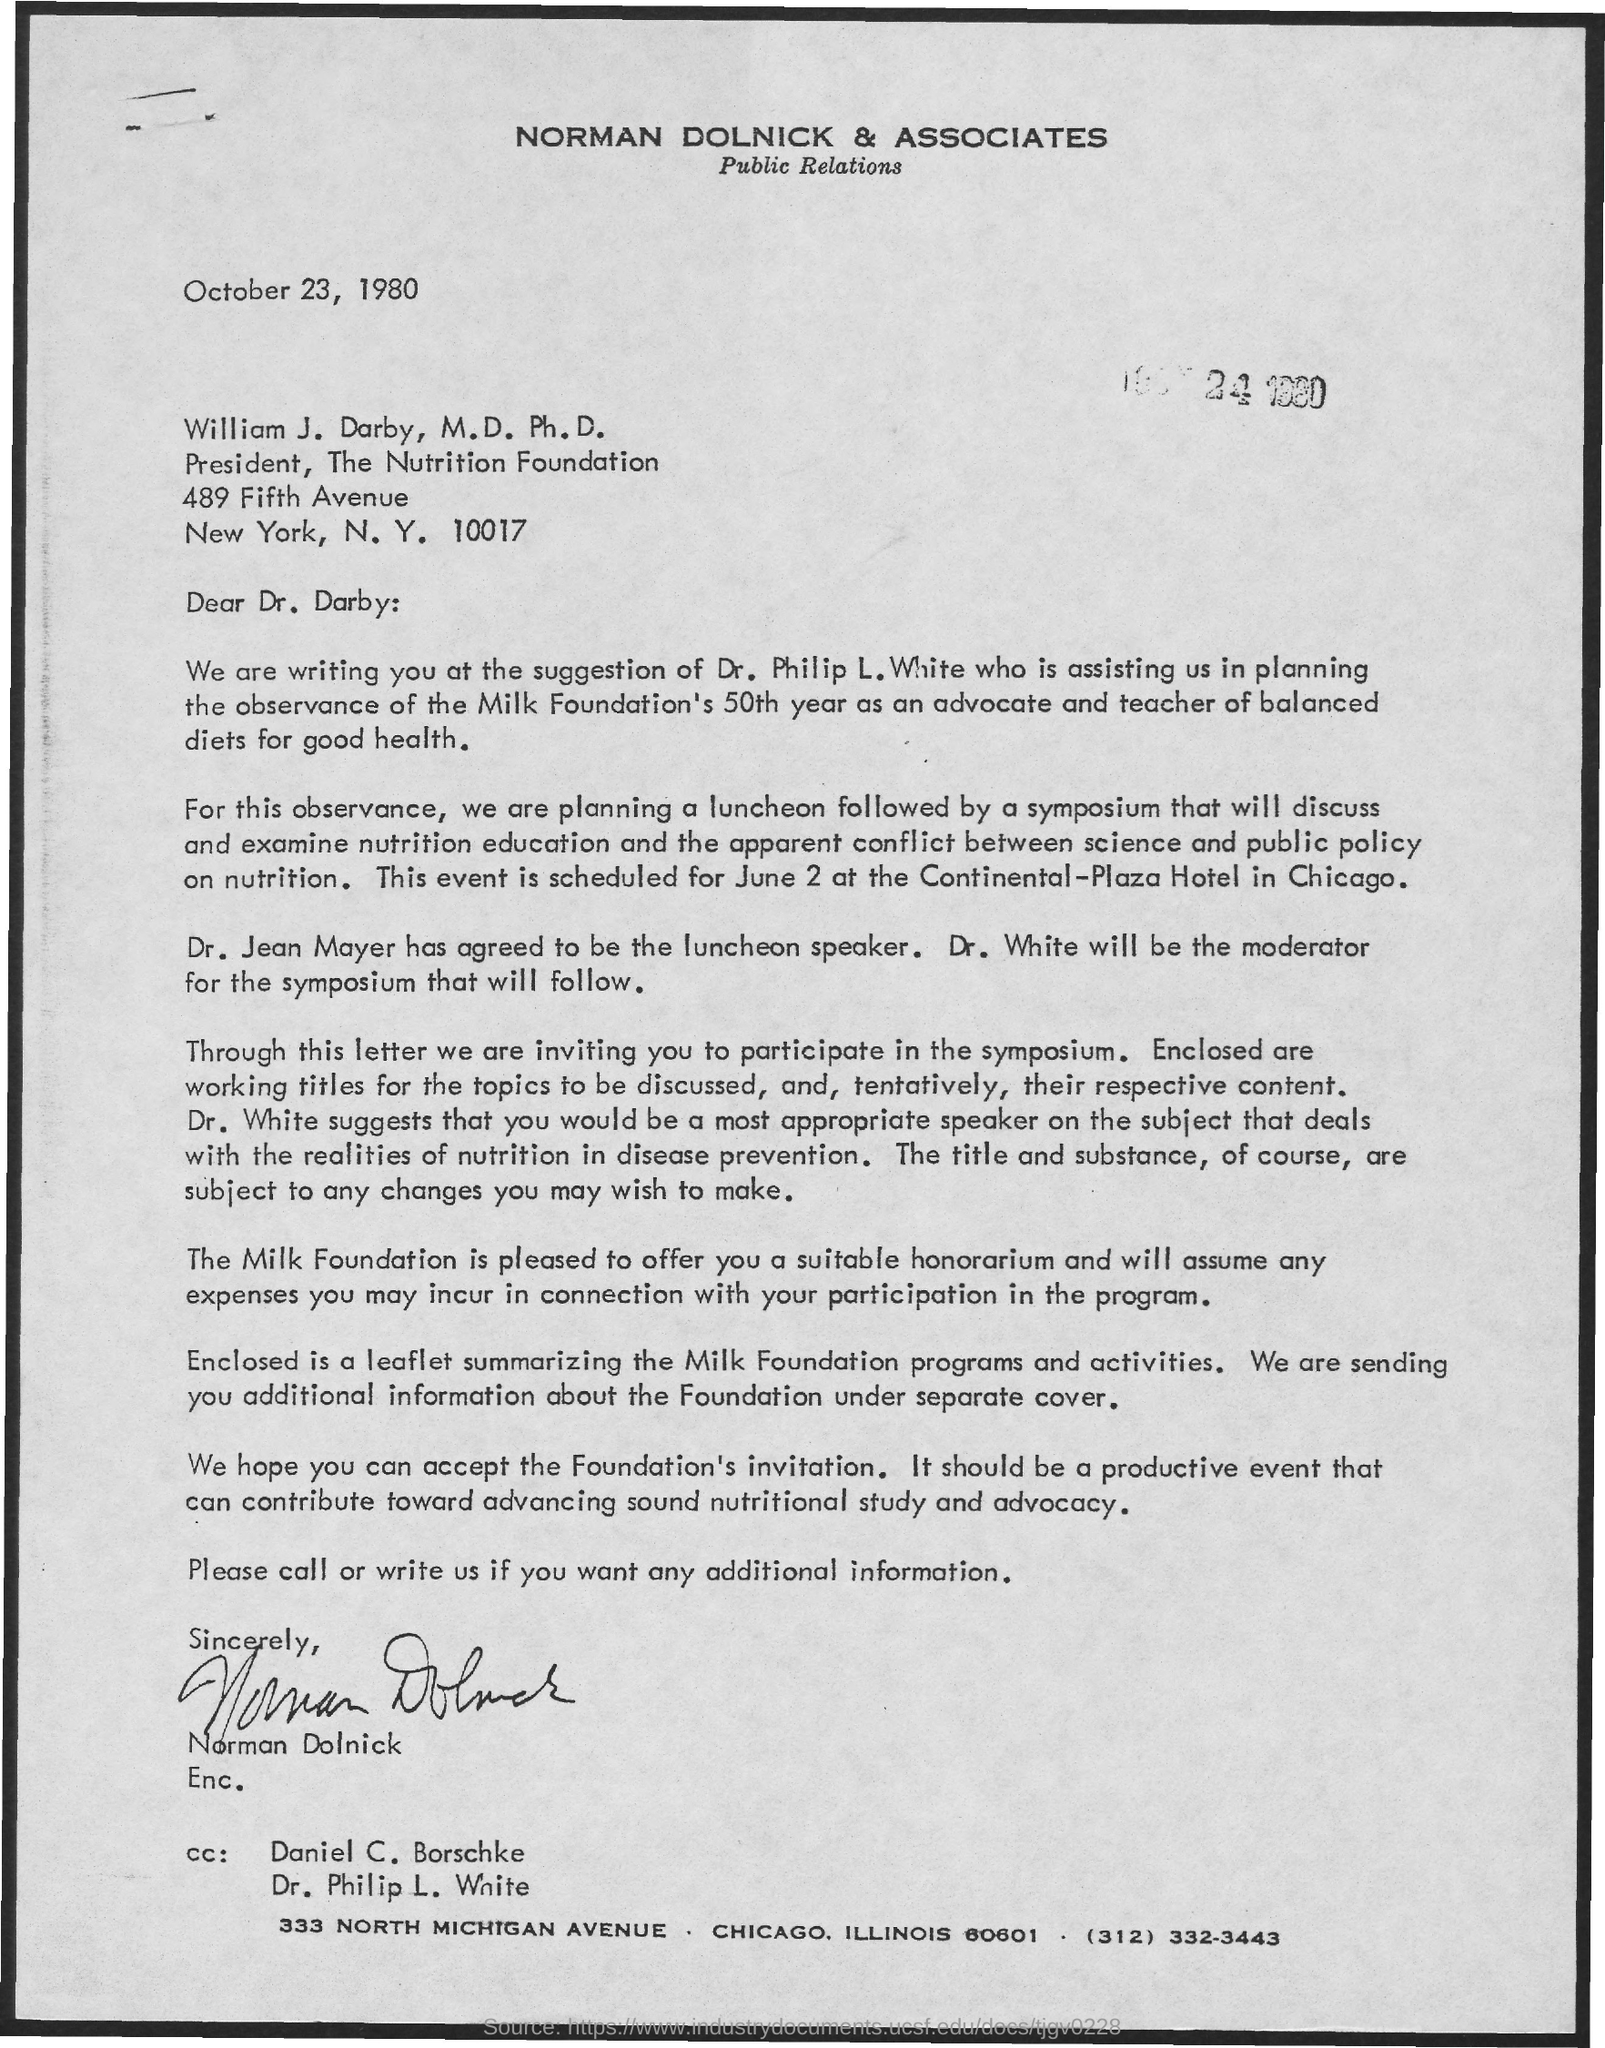Outline some significant characteristics in this image. The date on the document is October 23, 1980. The luncheon speaker is Dr. Jean Mayer. 